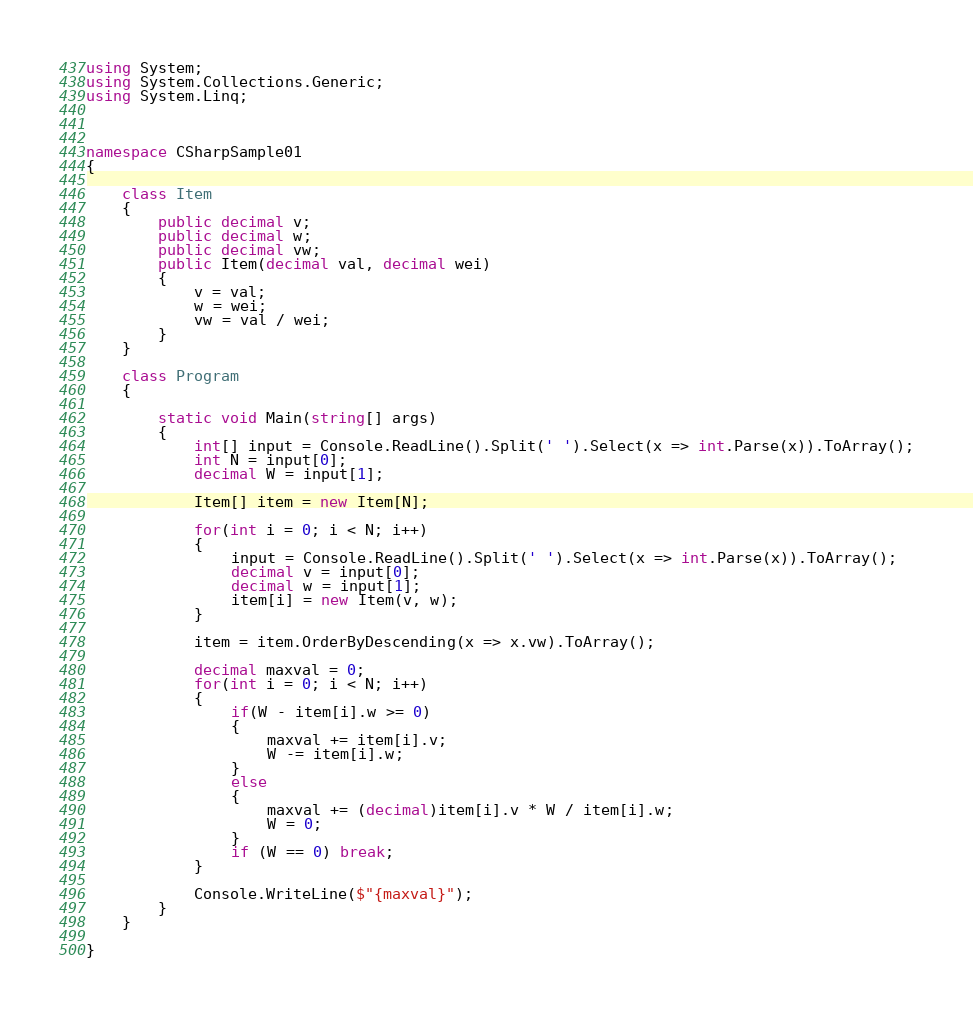Convert code to text. <code><loc_0><loc_0><loc_500><loc_500><_C#_>using System;
using System.Collections.Generic;
using System.Linq;



namespace CSharpSample01
{
    
    class Item
    {
        public decimal v;
        public decimal w;
        public decimal vw;
        public Item(decimal val, decimal wei)
        {
            v = val;
            w = wei;
            vw = val / wei;
        }
    }

    class Program
    {
        
        static void Main(string[] args)
        {
            int[] input = Console.ReadLine().Split(' ').Select(x => int.Parse(x)).ToArray();
            int N = input[0];
            decimal W = input[1];

            Item[] item = new Item[N];

            for(int i = 0; i < N; i++)
            {
                input = Console.ReadLine().Split(' ').Select(x => int.Parse(x)).ToArray();
                decimal v = input[0];
                decimal w = input[1];
                item[i] = new Item(v, w);
            }

            item = item.OrderByDescending(x => x.vw).ToArray();

            decimal maxval = 0;
            for(int i = 0; i < N; i++)
            {
                if(W - item[i].w >= 0)
                {
                    maxval += item[i].v;
                    W -= item[i].w;
                }
                else
                {
                    maxval += (decimal)item[i].v * W / item[i].w;
                    W = 0;
                }
                if (W == 0) break;
            }

            Console.WriteLine($"{maxval}");
        }
    }

}
</code> 